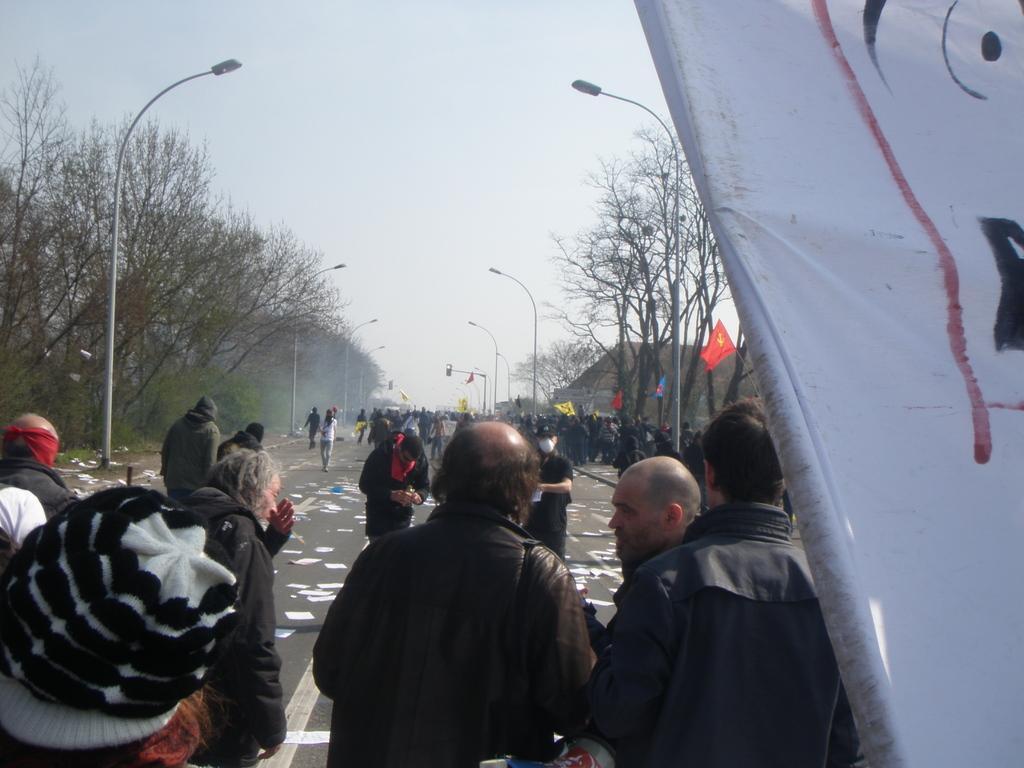How would you summarize this image in a sentence or two? In this image there is a road on which there are so many papers on it. There are few people walking on the road. On the right side there is a banner. There are light poles on the footpath. At the bottom there are few people talking with each other. There are trees on either side of the road. There are few flags on the footpath. 